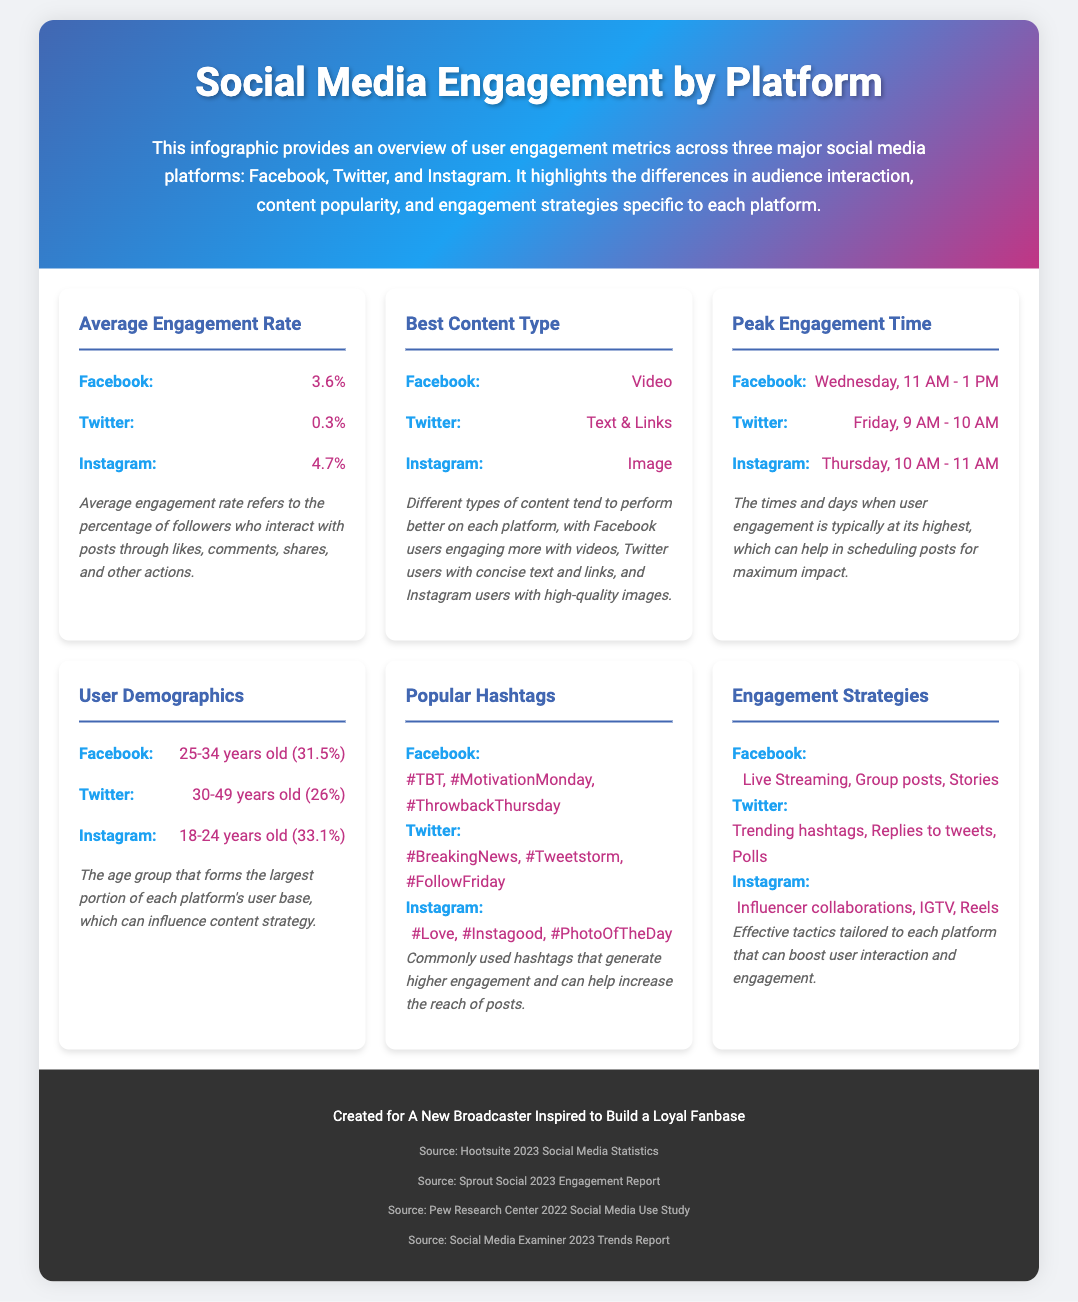What is the average engagement rate on Instagram? The average engagement rate on Instagram is presented as part of the metrics in the infographic, which indicates a rate of 4.7%.
Answer: 4.7% What type of content performs best on Twitter? The infographic lists the best content type for Twitter, which is indicated to be Text & Links.
Answer: Text & Links When is peak engagement time for Facebook? The peak engagement time for Facebook is detailed in the infographic, noted as Wednesday, 11 AM - 1 PM.
Answer: Wednesday, 11 AM - 1 PM What percentage of Facebook users are aged 25-34? The infographic specifies that 31.5% of Facebook users fall into the 25-34 age group.
Answer: 31.5% Which platform has the highest average engagement rate? Comparing the engagement rates listed in the infographic, the highest average engagement rate is for Instagram at 4.7%.
Answer: Instagram What are popular hashtags used on Instagram? The infographic provides a list of popular hashtags on Instagram, which includes #Love, #Instagood, and #PhotoOfTheDay.
Answer: #Love, #Instagood, #PhotoOfTheDay What engagement strategy is mentioned for Facebook? The infographic highlights various engagement strategies, with one mentioned specifically for Facebook being Live Streaming.
Answer: Live Streaming How do engagement rates on Twitter compare to Instagram? The document indicates that Twitter has a lower engagement rate of 0.3% compared to Instagram, which has an engagement rate of 4.7%.
Answer: 0.3% vs. 4.7% What is the source of the statistics provided in the infographic? The infographic lists various sources at the end, including Hootsuite 2023 Social Media Statistics as one of the sources.
Answer: Hootsuite 2023 Social Media Statistics 